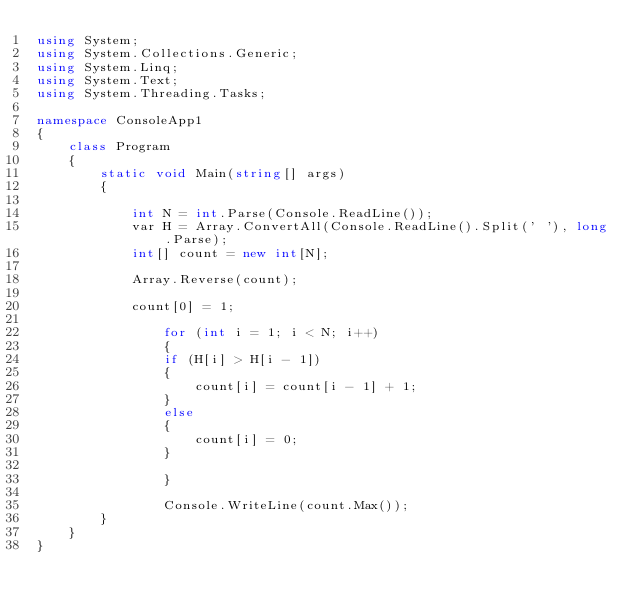Convert code to text. <code><loc_0><loc_0><loc_500><loc_500><_C#_>using System;
using System.Collections.Generic;
using System.Linq;
using System.Text;
using System.Threading.Tasks;

namespace ConsoleApp1
{
    class Program
    {
        static void Main(string[] args)
        {

            int N = int.Parse(Console.ReadLine());
            var H = Array.ConvertAll(Console.ReadLine().Split(' '), long.Parse);
            int[] count = new int[N];

            Array.Reverse(count);

            count[0] = 1;
            
                for (int i = 1; i < N; i++)
                {
                if (H[i] > H[i - 1])
                {
                    count[i] = count[i - 1] + 1;
                }
                else
                {
                    count[i] = 0;
                }
                
                }
                
                Console.WriteLine(count.Max());
        }
    }
}
</code> 